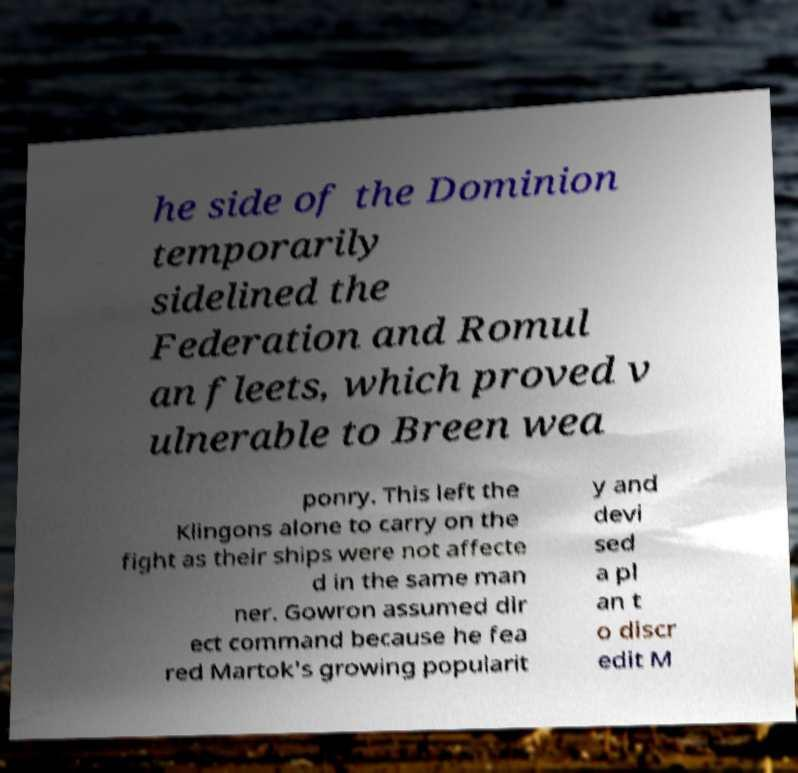Could you assist in decoding the text presented in this image and type it out clearly? he side of the Dominion temporarily sidelined the Federation and Romul an fleets, which proved v ulnerable to Breen wea ponry. This left the Klingons alone to carry on the fight as their ships were not affecte d in the same man ner. Gowron assumed dir ect command because he fea red Martok's growing popularit y and devi sed a pl an t o discr edit M 